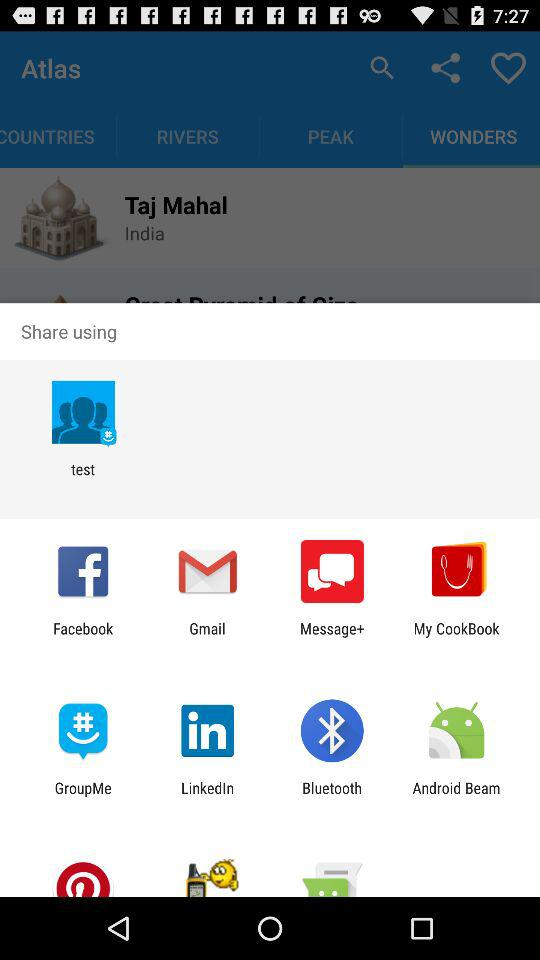How many unread messages are there?
When the provided information is insufficient, respond with <no answer>. <no answer> 